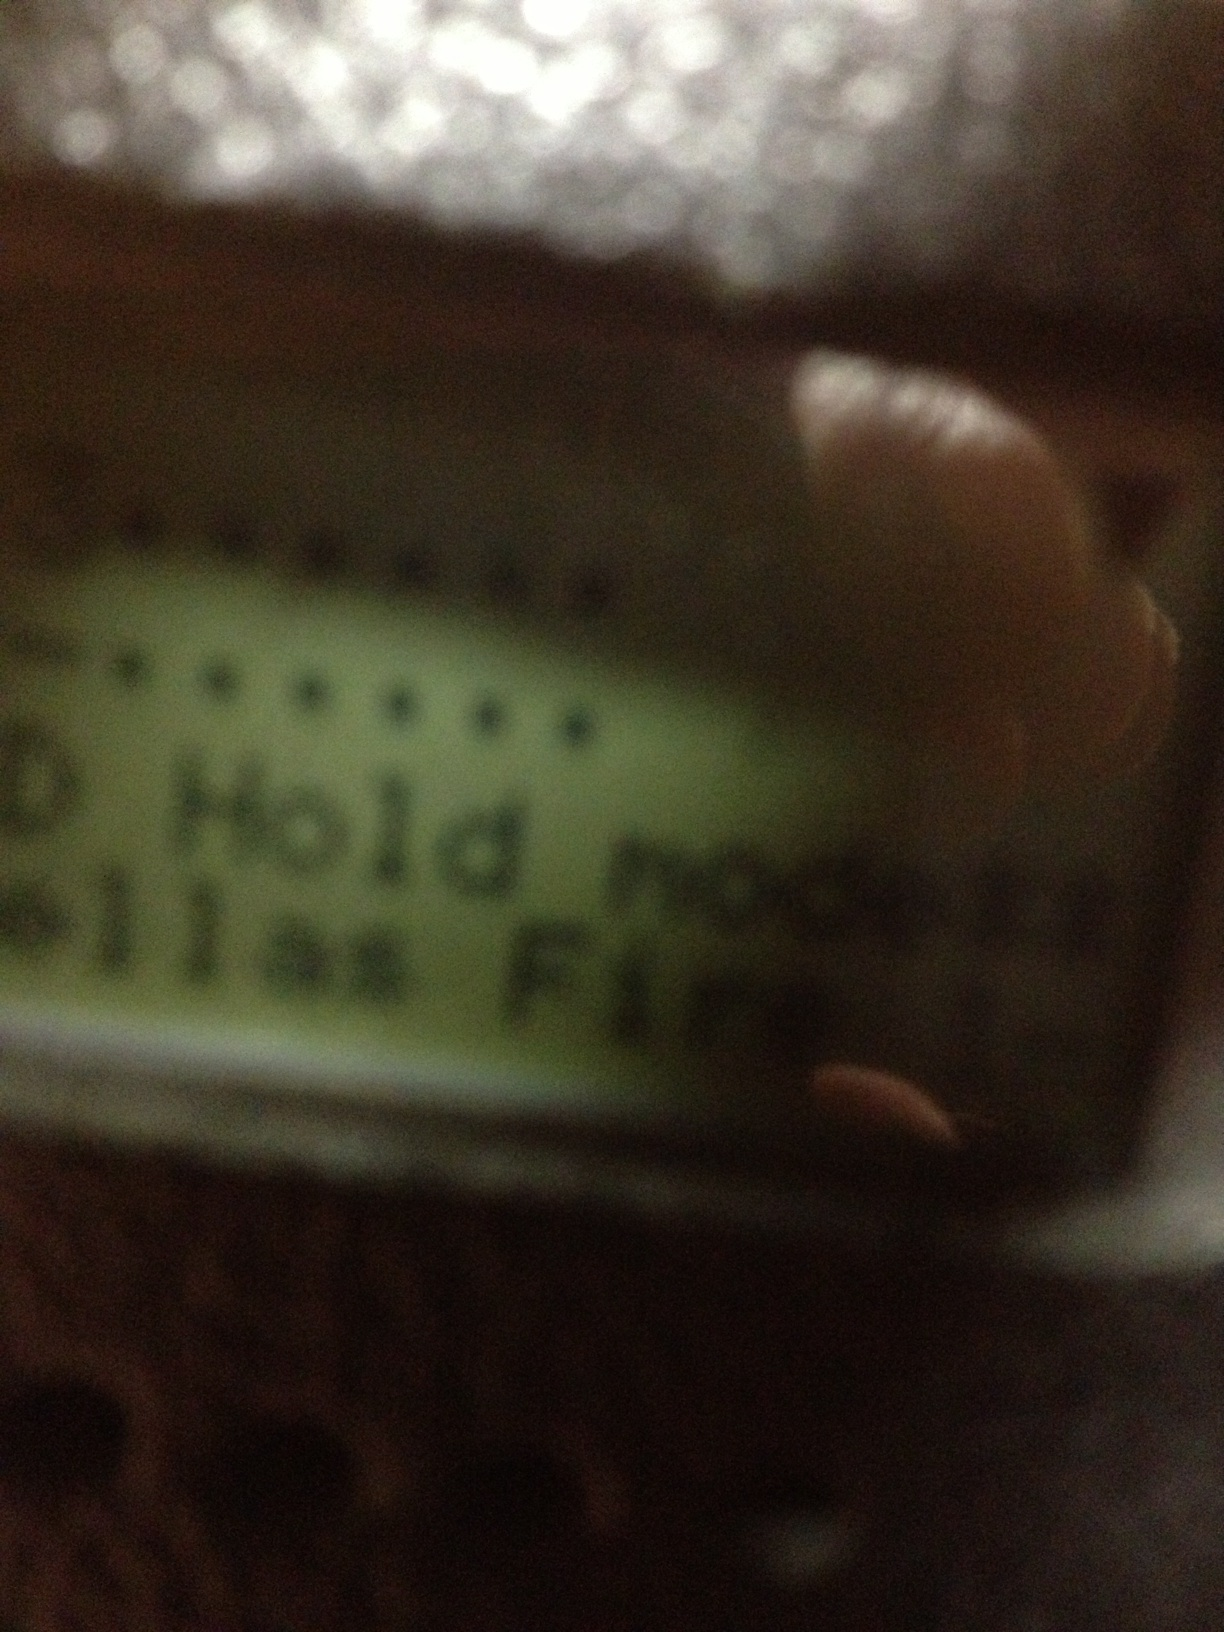Tell me what's on the screen. The screen displays 'Hold mode', indicating that the device is currently in a state where interactions or operations are being temporarily paused or held. 